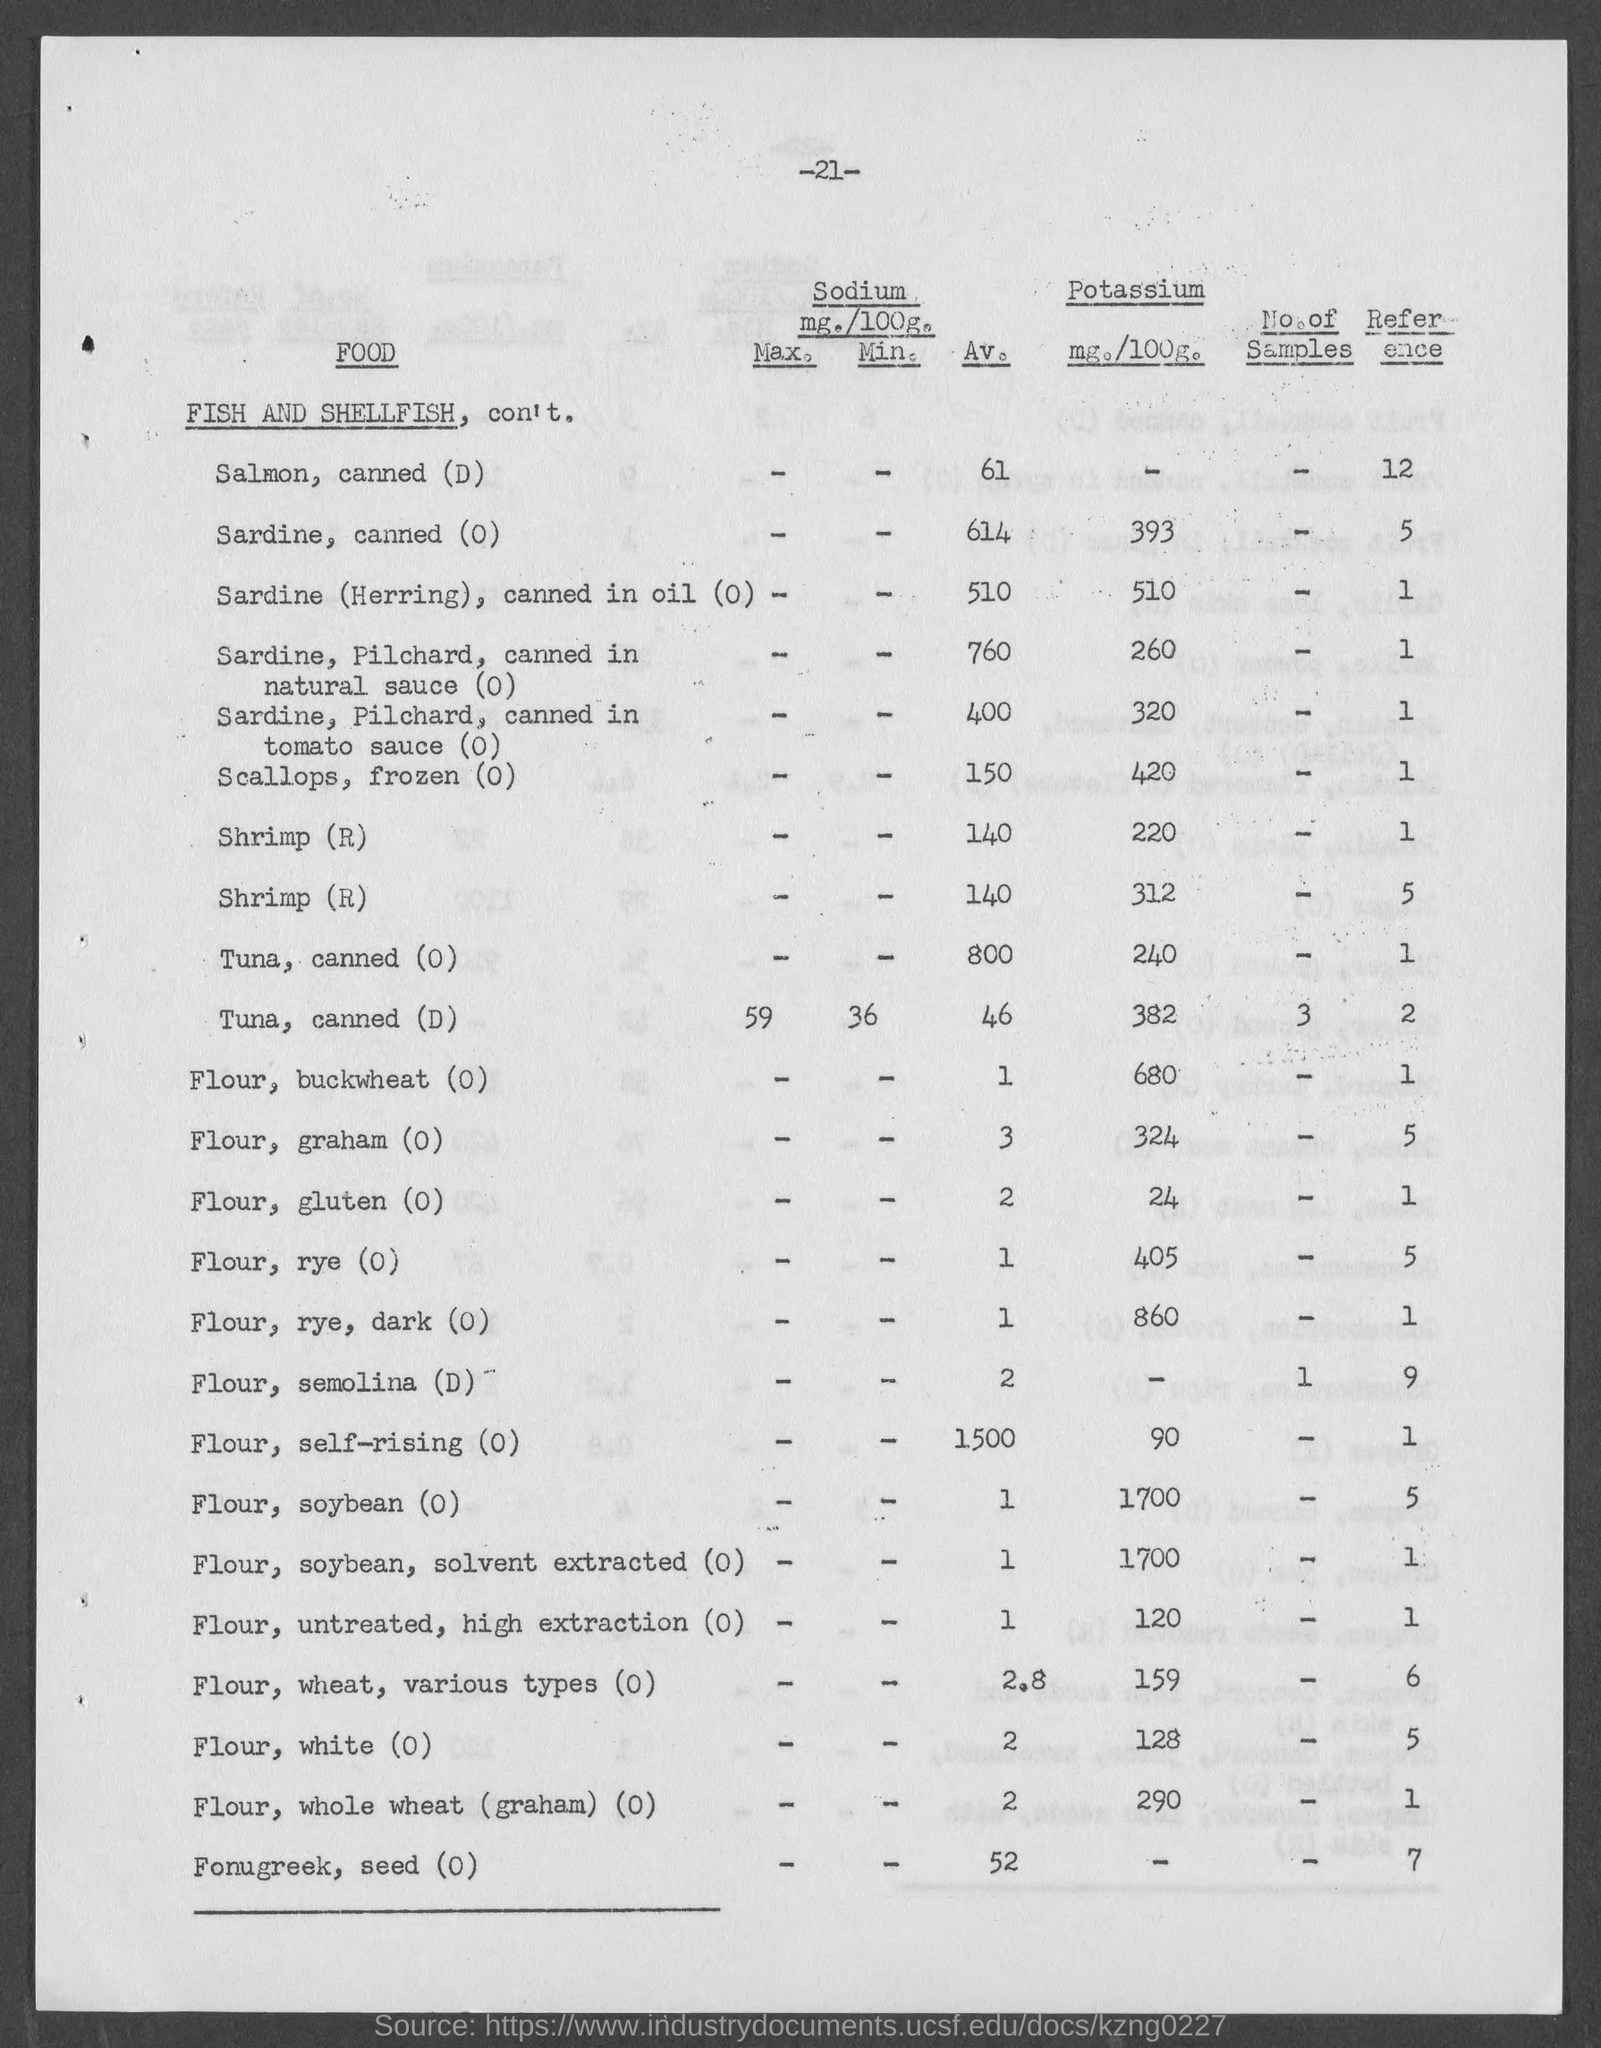What is the Av. Sodium for Salmon, canned (D)?
Ensure brevity in your answer.  61. What is the Av. Sodium for Sardine, canned (0)?
Keep it short and to the point. 614. What is the Av. Sodium for Sardine(Herring), canned in oil(0)?
Offer a very short reply. 510. What is the Av. Sodium for Scallops, frozen (0)?
Give a very brief answer. 150. What is the Av. Sodium for Shrimp (R)?
Provide a short and direct response. 140. What is the Av. Sodium for Tuna, canned (D)?
Offer a terse response. 46. What is the Av. Sodium for Tuna, canned (0)?
Your answer should be very brief. 800. What is the Av. Sodium for Flour, Buckwheat (0)?
Your answer should be compact. 1. What is the Av. Sodium for Flour, graham (0)?
Give a very brief answer. 3. What is the Av. Sodium for Flour, gluten (0)?
Offer a terse response. 2. 